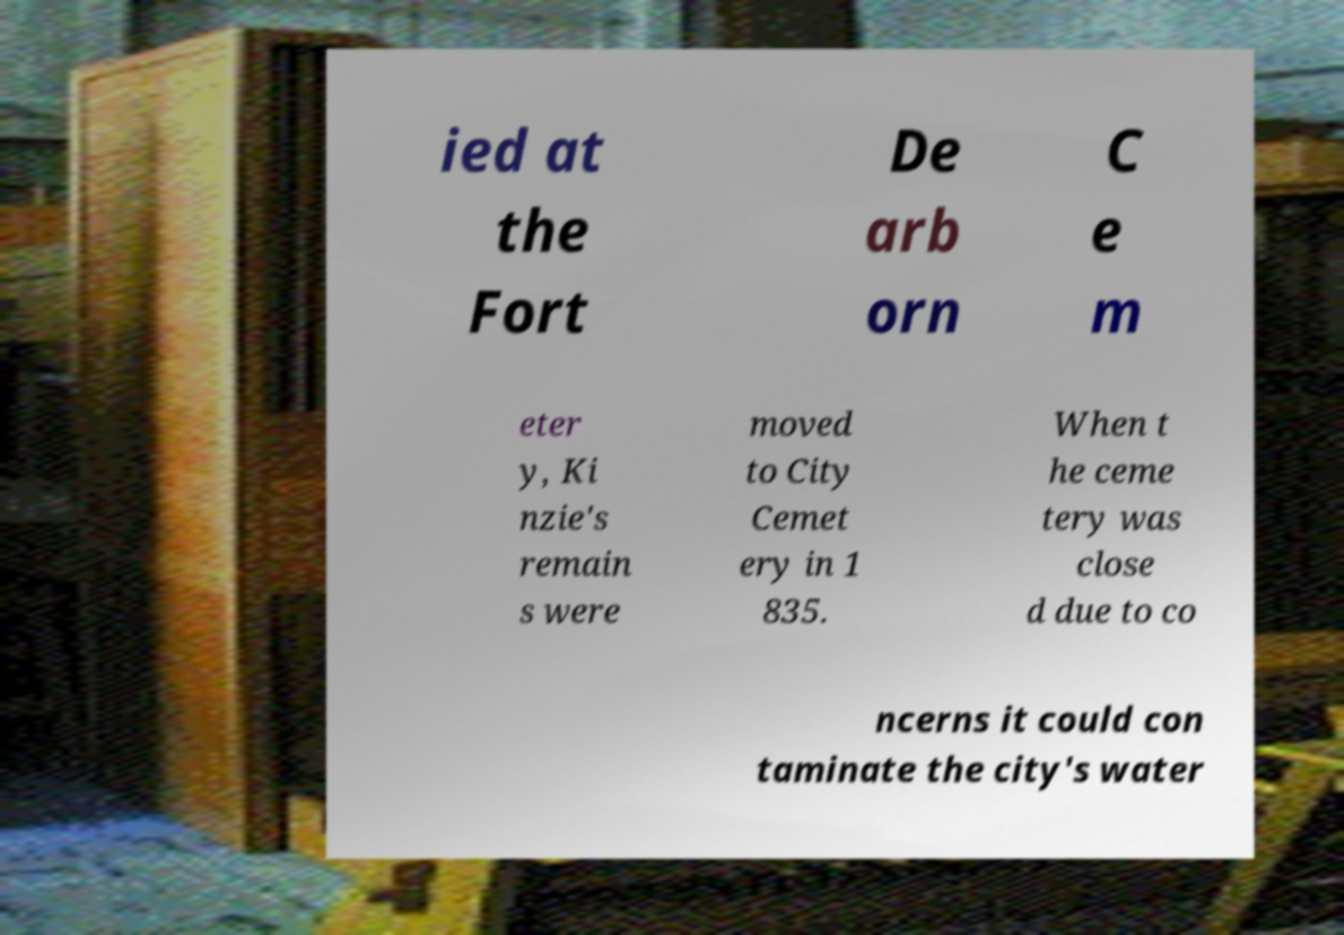Can you accurately transcribe the text from the provided image for me? ied at the Fort De arb orn C e m eter y, Ki nzie's remain s were moved to City Cemet ery in 1 835. When t he ceme tery was close d due to co ncerns it could con taminate the city's water 